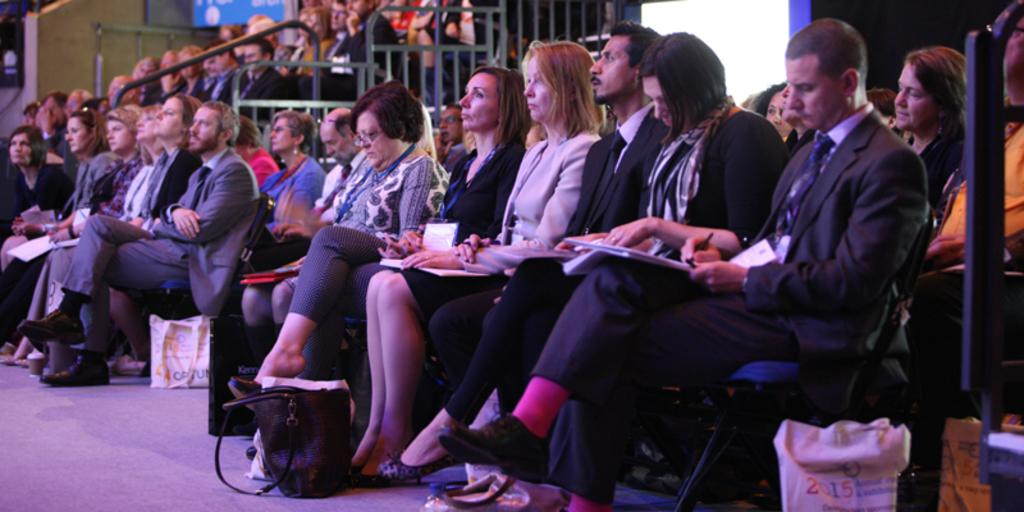What types of people are present in the image? There are men and women in the image. What are the people doing in the image? The people are sitting on chairs. What are the people wearing in the image? The people are wearing suits. What kind of location does the image appear to depict? The setting appears to be a conference hall. Can you tell me how many fangs are visible in the image? There are no fangs present in the image; it features men and women wearing suits and sitting in a conference hall. 